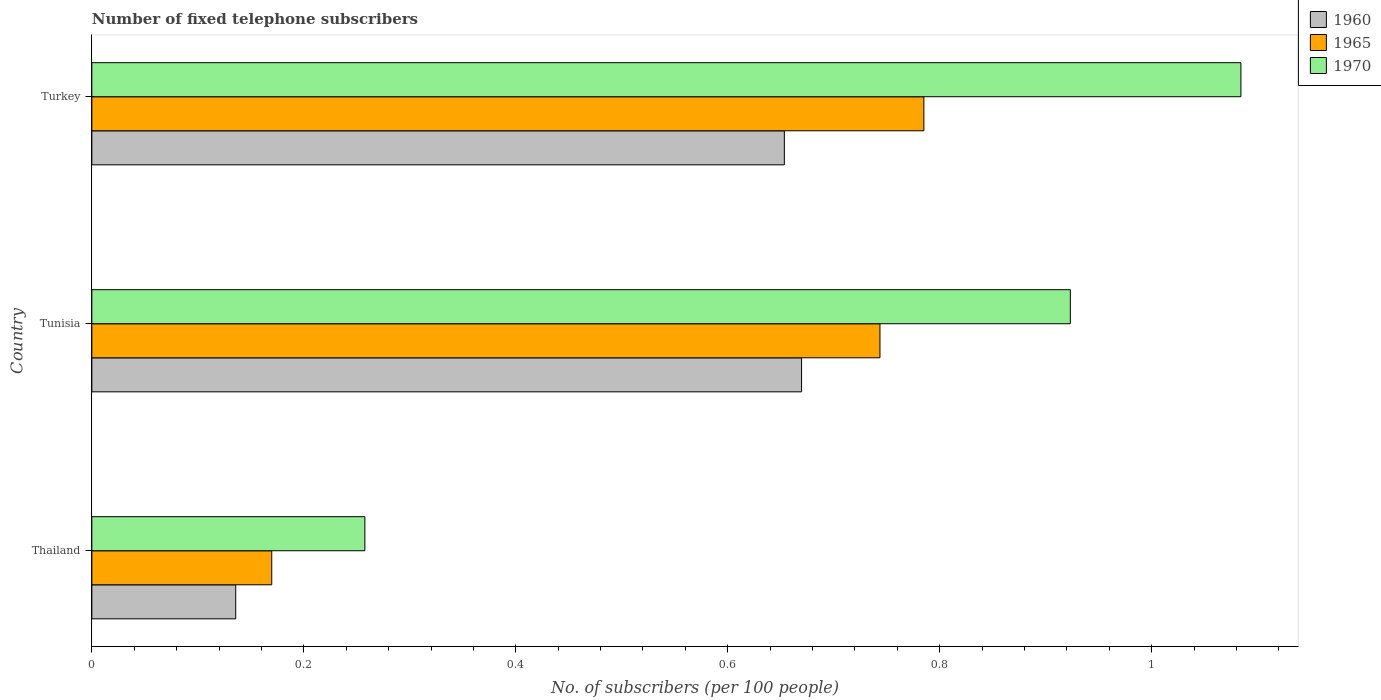How many different coloured bars are there?
Provide a short and direct response. 3. Are the number of bars per tick equal to the number of legend labels?
Make the answer very short. Yes. How many bars are there on the 1st tick from the top?
Your answer should be compact. 3. In how many cases, is the number of bars for a given country not equal to the number of legend labels?
Ensure brevity in your answer.  0. What is the number of fixed telephone subscribers in 1960 in Turkey?
Ensure brevity in your answer.  0.65. Across all countries, what is the maximum number of fixed telephone subscribers in 1960?
Ensure brevity in your answer.  0.67. Across all countries, what is the minimum number of fixed telephone subscribers in 1960?
Provide a succinct answer. 0.14. In which country was the number of fixed telephone subscribers in 1970 minimum?
Offer a terse response. Thailand. What is the total number of fixed telephone subscribers in 1965 in the graph?
Your response must be concise. 1.7. What is the difference between the number of fixed telephone subscribers in 1960 in Thailand and that in Turkey?
Your answer should be compact. -0.52. What is the difference between the number of fixed telephone subscribers in 1960 in Thailand and the number of fixed telephone subscribers in 1970 in Tunisia?
Ensure brevity in your answer.  -0.79. What is the average number of fixed telephone subscribers in 1960 per country?
Your answer should be very brief. 0.49. What is the difference between the number of fixed telephone subscribers in 1960 and number of fixed telephone subscribers in 1970 in Turkey?
Your answer should be very brief. -0.43. What is the ratio of the number of fixed telephone subscribers in 1960 in Thailand to that in Tunisia?
Provide a short and direct response. 0.2. Is the difference between the number of fixed telephone subscribers in 1960 in Thailand and Tunisia greater than the difference between the number of fixed telephone subscribers in 1970 in Thailand and Tunisia?
Offer a terse response. Yes. What is the difference between the highest and the second highest number of fixed telephone subscribers in 1970?
Offer a terse response. 0.16. What is the difference between the highest and the lowest number of fixed telephone subscribers in 1960?
Provide a short and direct response. 0.53. In how many countries, is the number of fixed telephone subscribers in 1970 greater than the average number of fixed telephone subscribers in 1970 taken over all countries?
Ensure brevity in your answer.  2. What does the 1st bar from the top in Tunisia represents?
Offer a terse response. 1970. What does the 2nd bar from the bottom in Thailand represents?
Give a very brief answer. 1965. Are all the bars in the graph horizontal?
Make the answer very short. Yes. What is the difference between two consecutive major ticks on the X-axis?
Offer a terse response. 0.2. Are the values on the major ticks of X-axis written in scientific E-notation?
Offer a terse response. No. Does the graph contain any zero values?
Provide a succinct answer. No. Does the graph contain grids?
Your answer should be very brief. No. Where does the legend appear in the graph?
Ensure brevity in your answer.  Top right. How many legend labels are there?
Ensure brevity in your answer.  3. How are the legend labels stacked?
Your answer should be compact. Vertical. What is the title of the graph?
Make the answer very short. Number of fixed telephone subscribers. Does "1982" appear as one of the legend labels in the graph?
Your response must be concise. No. What is the label or title of the X-axis?
Your answer should be compact. No. of subscribers (per 100 people). What is the No. of subscribers (per 100 people) in 1960 in Thailand?
Ensure brevity in your answer.  0.14. What is the No. of subscribers (per 100 people) in 1965 in Thailand?
Give a very brief answer. 0.17. What is the No. of subscribers (per 100 people) in 1970 in Thailand?
Give a very brief answer. 0.26. What is the No. of subscribers (per 100 people) of 1960 in Tunisia?
Your response must be concise. 0.67. What is the No. of subscribers (per 100 people) in 1965 in Tunisia?
Make the answer very short. 0.74. What is the No. of subscribers (per 100 people) in 1970 in Tunisia?
Offer a very short reply. 0.92. What is the No. of subscribers (per 100 people) of 1960 in Turkey?
Give a very brief answer. 0.65. What is the No. of subscribers (per 100 people) in 1965 in Turkey?
Offer a very short reply. 0.79. What is the No. of subscribers (per 100 people) of 1970 in Turkey?
Your answer should be very brief. 1.08. Across all countries, what is the maximum No. of subscribers (per 100 people) in 1960?
Keep it short and to the point. 0.67. Across all countries, what is the maximum No. of subscribers (per 100 people) in 1965?
Offer a terse response. 0.79. Across all countries, what is the maximum No. of subscribers (per 100 people) in 1970?
Give a very brief answer. 1.08. Across all countries, what is the minimum No. of subscribers (per 100 people) of 1960?
Give a very brief answer. 0.14. Across all countries, what is the minimum No. of subscribers (per 100 people) in 1965?
Offer a terse response. 0.17. Across all countries, what is the minimum No. of subscribers (per 100 people) in 1970?
Keep it short and to the point. 0.26. What is the total No. of subscribers (per 100 people) in 1960 in the graph?
Make the answer very short. 1.46. What is the total No. of subscribers (per 100 people) of 1965 in the graph?
Provide a short and direct response. 1.7. What is the total No. of subscribers (per 100 people) of 1970 in the graph?
Offer a very short reply. 2.27. What is the difference between the No. of subscribers (per 100 people) of 1960 in Thailand and that in Tunisia?
Make the answer very short. -0.53. What is the difference between the No. of subscribers (per 100 people) in 1965 in Thailand and that in Tunisia?
Provide a succinct answer. -0.57. What is the difference between the No. of subscribers (per 100 people) in 1970 in Thailand and that in Tunisia?
Ensure brevity in your answer.  -0.67. What is the difference between the No. of subscribers (per 100 people) of 1960 in Thailand and that in Turkey?
Provide a short and direct response. -0.52. What is the difference between the No. of subscribers (per 100 people) in 1965 in Thailand and that in Turkey?
Give a very brief answer. -0.62. What is the difference between the No. of subscribers (per 100 people) in 1970 in Thailand and that in Turkey?
Make the answer very short. -0.83. What is the difference between the No. of subscribers (per 100 people) in 1960 in Tunisia and that in Turkey?
Ensure brevity in your answer.  0.02. What is the difference between the No. of subscribers (per 100 people) of 1965 in Tunisia and that in Turkey?
Ensure brevity in your answer.  -0.04. What is the difference between the No. of subscribers (per 100 people) in 1970 in Tunisia and that in Turkey?
Give a very brief answer. -0.16. What is the difference between the No. of subscribers (per 100 people) in 1960 in Thailand and the No. of subscribers (per 100 people) in 1965 in Tunisia?
Offer a terse response. -0.61. What is the difference between the No. of subscribers (per 100 people) of 1960 in Thailand and the No. of subscribers (per 100 people) of 1970 in Tunisia?
Make the answer very short. -0.79. What is the difference between the No. of subscribers (per 100 people) in 1965 in Thailand and the No. of subscribers (per 100 people) in 1970 in Tunisia?
Your answer should be very brief. -0.75. What is the difference between the No. of subscribers (per 100 people) in 1960 in Thailand and the No. of subscribers (per 100 people) in 1965 in Turkey?
Your response must be concise. -0.65. What is the difference between the No. of subscribers (per 100 people) in 1960 in Thailand and the No. of subscribers (per 100 people) in 1970 in Turkey?
Your answer should be compact. -0.95. What is the difference between the No. of subscribers (per 100 people) of 1965 in Thailand and the No. of subscribers (per 100 people) of 1970 in Turkey?
Provide a succinct answer. -0.91. What is the difference between the No. of subscribers (per 100 people) in 1960 in Tunisia and the No. of subscribers (per 100 people) in 1965 in Turkey?
Your answer should be very brief. -0.12. What is the difference between the No. of subscribers (per 100 people) in 1960 in Tunisia and the No. of subscribers (per 100 people) in 1970 in Turkey?
Your response must be concise. -0.41. What is the difference between the No. of subscribers (per 100 people) in 1965 in Tunisia and the No. of subscribers (per 100 people) in 1970 in Turkey?
Provide a short and direct response. -0.34. What is the average No. of subscribers (per 100 people) in 1960 per country?
Offer a terse response. 0.49. What is the average No. of subscribers (per 100 people) of 1965 per country?
Keep it short and to the point. 0.57. What is the average No. of subscribers (per 100 people) in 1970 per country?
Offer a very short reply. 0.76. What is the difference between the No. of subscribers (per 100 people) in 1960 and No. of subscribers (per 100 people) in 1965 in Thailand?
Offer a terse response. -0.03. What is the difference between the No. of subscribers (per 100 people) of 1960 and No. of subscribers (per 100 people) of 1970 in Thailand?
Your answer should be compact. -0.12. What is the difference between the No. of subscribers (per 100 people) in 1965 and No. of subscribers (per 100 people) in 1970 in Thailand?
Give a very brief answer. -0.09. What is the difference between the No. of subscribers (per 100 people) of 1960 and No. of subscribers (per 100 people) of 1965 in Tunisia?
Your answer should be compact. -0.07. What is the difference between the No. of subscribers (per 100 people) in 1960 and No. of subscribers (per 100 people) in 1970 in Tunisia?
Your answer should be compact. -0.25. What is the difference between the No. of subscribers (per 100 people) in 1965 and No. of subscribers (per 100 people) in 1970 in Tunisia?
Keep it short and to the point. -0.18. What is the difference between the No. of subscribers (per 100 people) of 1960 and No. of subscribers (per 100 people) of 1965 in Turkey?
Your answer should be compact. -0.13. What is the difference between the No. of subscribers (per 100 people) in 1960 and No. of subscribers (per 100 people) in 1970 in Turkey?
Ensure brevity in your answer.  -0.43. What is the difference between the No. of subscribers (per 100 people) in 1965 and No. of subscribers (per 100 people) in 1970 in Turkey?
Your answer should be compact. -0.3. What is the ratio of the No. of subscribers (per 100 people) of 1960 in Thailand to that in Tunisia?
Provide a short and direct response. 0.2. What is the ratio of the No. of subscribers (per 100 people) in 1965 in Thailand to that in Tunisia?
Give a very brief answer. 0.23. What is the ratio of the No. of subscribers (per 100 people) in 1970 in Thailand to that in Tunisia?
Provide a succinct answer. 0.28. What is the ratio of the No. of subscribers (per 100 people) in 1960 in Thailand to that in Turkey?
Your answer should be compact. 0.21. What is the ratio of the No. of subscribers (per 100 people) in 1965 in Thailand to that in Turkey?
Offer a very short reply. 0.22. What is the ratio of the No. of subscribers (per 100 people) in 1970 in Thailand to that in Turkey?
Ensure brevity in your answer.  0.24. What is the ratio of the No. of subscribers (per 100 people) of 1960 in Tunisia to that in Turkey?
Offer a very short reply. 1.02. What is the ratio of the No. of subscribers (per 100 people) of 1965 in Tunisia to that in Turkey?
Your response must be concise. 0.95. What is the ratio of the No. of subscribers (per 100 people) in 1970 in Tunisia to that in Turkey?
Your response must be concise. 0.85. What is the difference between the highest and the second highest No. of subscribers (per 100 people) in 1960?
Make the answer very short. 0.02. What is the difference between the highest and the second highest No. of subscribers (per 100 people) in 1965?
Keep it short and to the point. 0.04. What is the difference between the highest and the second highest No. of subscribers (per 100 people) in 1970?
Make the answer very short. 0.16. What is the difference between the highest and the lowest No. of subscribers (per 100 people) of 1960?
Provide a succinct answer. 0.53. What is the difference between the highest and the lowest No. of subscribers (per 100 people) in 1965?
Offer a terse response. 0.62. What is the difference between the highest and the lowest No. of subscribers (per 100 people) in 1970?
Provide a succinct answer. 0.83. 